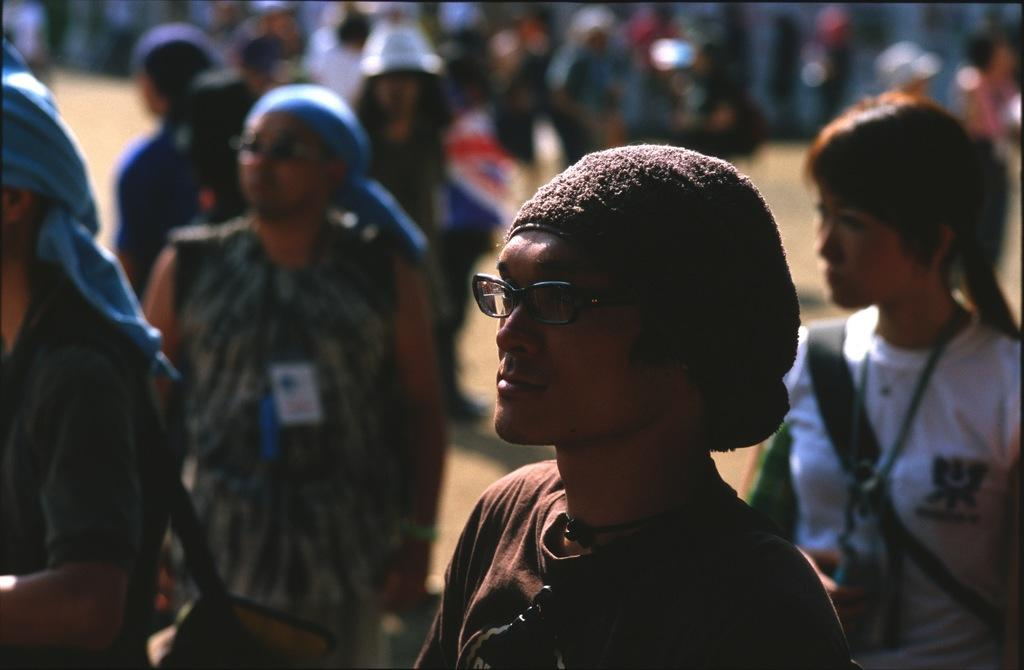What is the main subject of the image? The main subject of the image is a man. Can you describe the man's appearance? The man is wearing spectacles, a t-shirt, and a cap. Are there any other people visible in the image? Yes, there are people standing in the background of the image. How would you describe the background of the image? The background of the image appears blurry. What type of beast can be seen entering the door in the image? There is no beast or door present in the image; it features a man wearing spectacles, a t-shirt, and a cap, with people standing in the background of a blurry scene. 